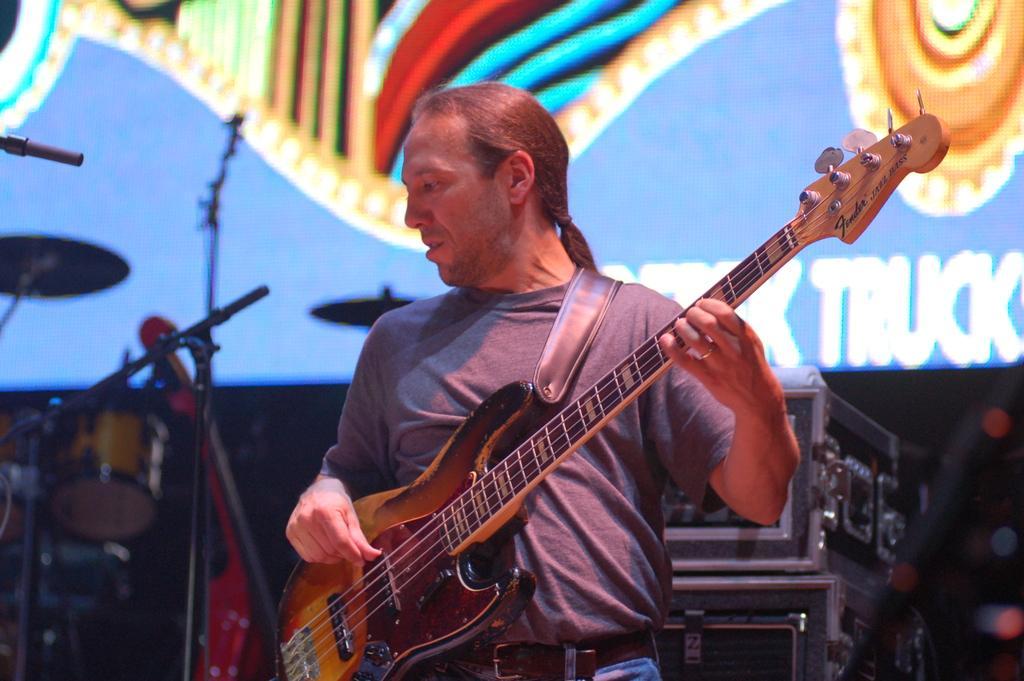Can you describe this image briefly? In this picture we can see we can see a man standing and playing a guitar. On the background there is a screen. These are the musical instruments. 